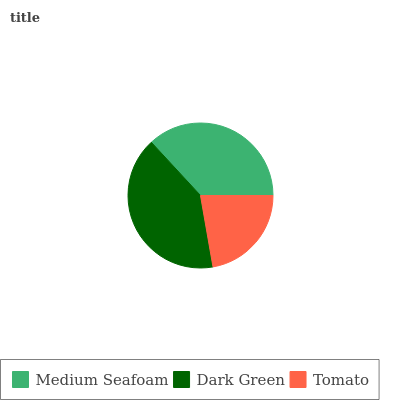Is Tomato the minimum?
Answer yes or no. Yes. Is Dark Green the maximum?
Answer yes or no. Yes. Is Dark Green the minimum?
Answer yes or no. No. Is Tomato the maximum?
Answer yes or no. No. Is Dark Green greater than Tomato?
Answer yes or no. Yes. Is Tomato less than Dark Green?
Answer yes or no. Yes. Is Tomato greater than Dark Green?
Answer yes or no. No. Is Dark Green less than Tomato?
Answer yes or no. No. Is Medium Seafoam the high median?
Answer yes or no. Yes. Is Medium Seafoam the low median?
Answer yes or no. Yes. Is Dark Green the high median?
Answer yes or no. No. Is Tomato the low median?
Answer yes or no. No. 